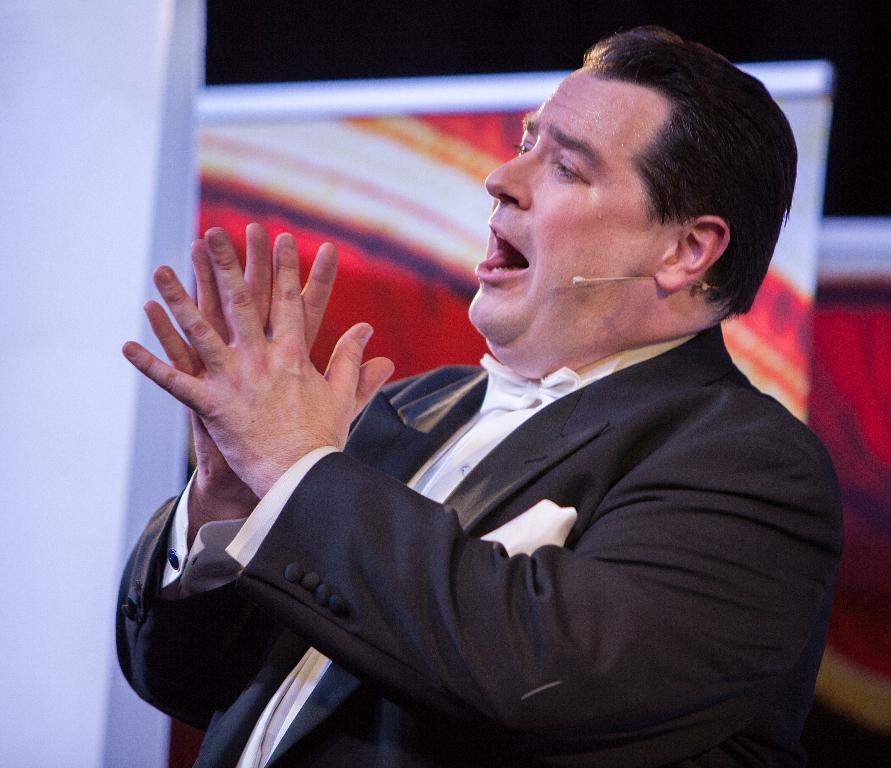Can you describe this image briefly? In the center of the image there is a person wearing a suit. In the background of the image there are banners. 